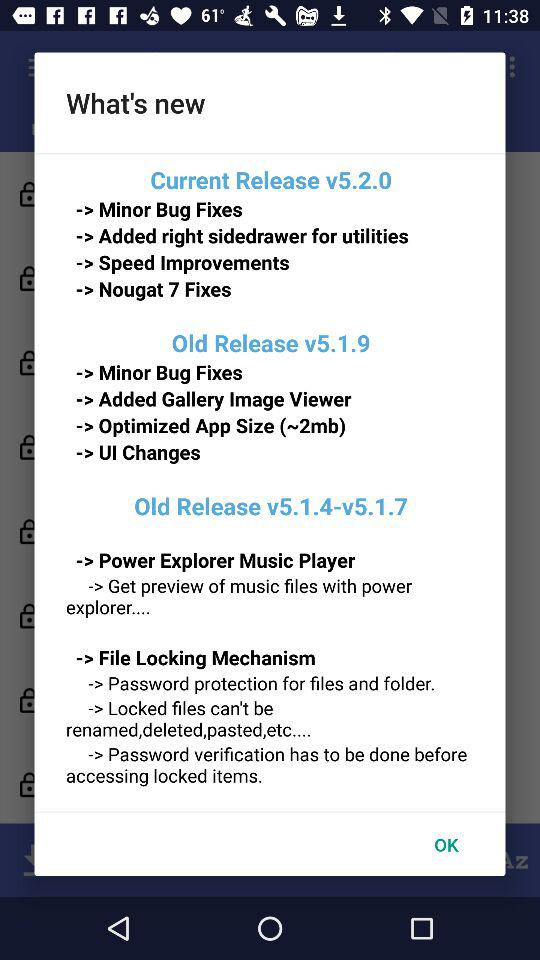What is the old version number? The old version numbers are v5.1.9 and v5.1.4–v5.1.7. 